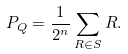Convert formula to latex. <formula><loc_0><loc_0><loc_500><loc_500>P _ { Q } = \frac { 1 } { 2 ^ { n } } \sum _ { R \in S } R .</formula> 